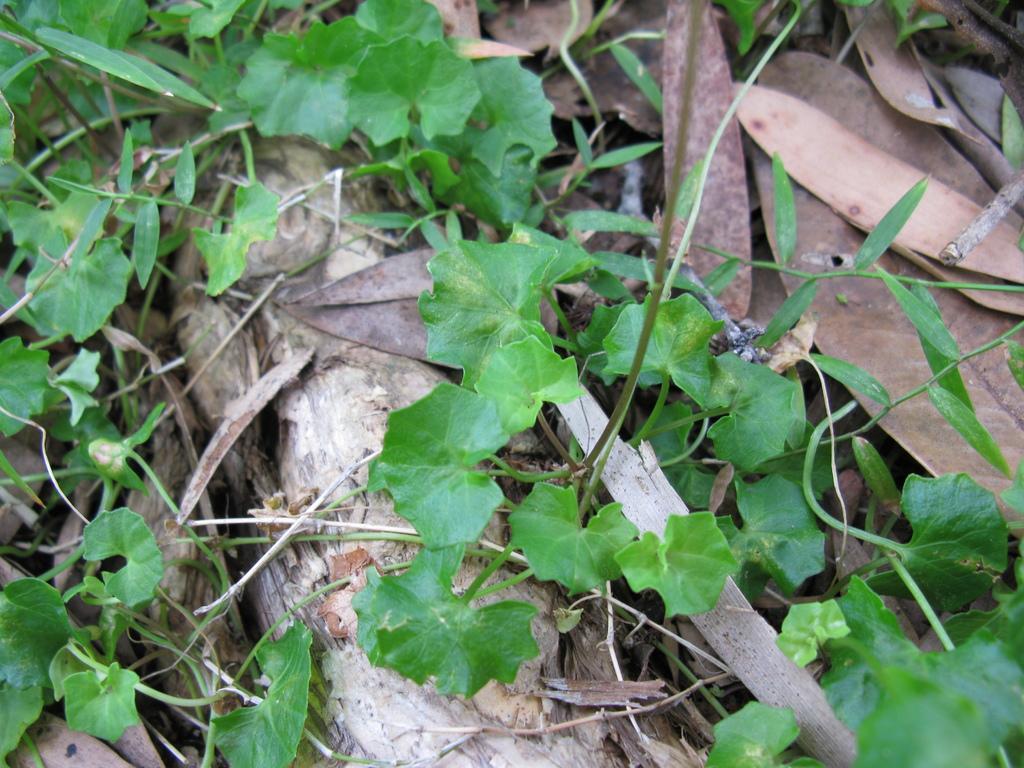Please provide a concise description of this image. In this image, we can see some plants and wood. We can see some dried leaves. 